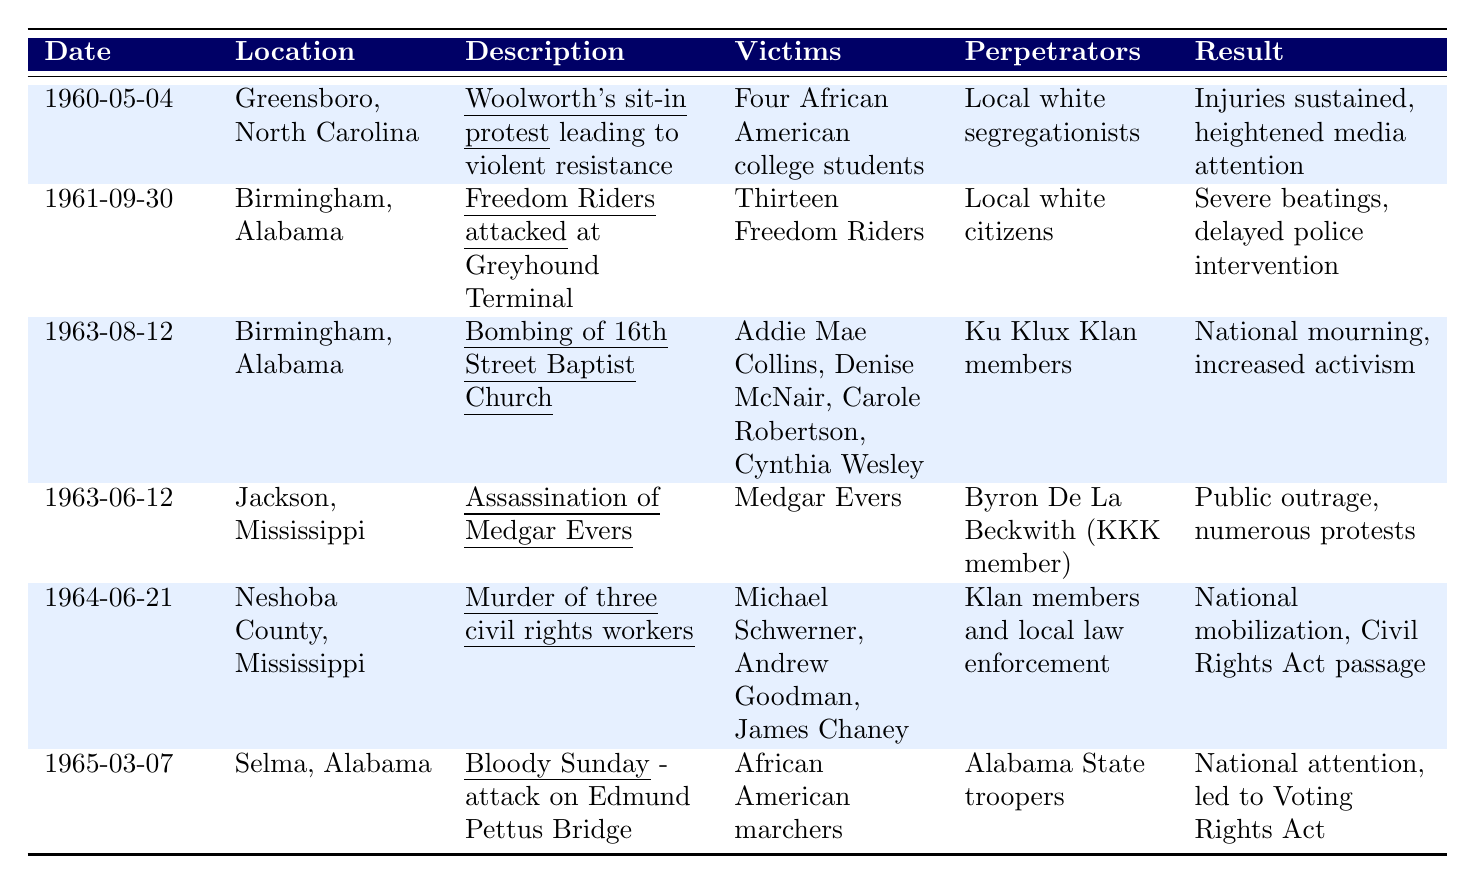What incident occurred on May 4, 1960? The table indicates that on May 4, 1960, in Greensboro, North Carolina, a Woolworth's sit-in protest led to violent resistance from white patrons.
Answer: Woolworth's sit-in protest How many victims were involved in the Freedom Riders incident? Referring to the table, it states that the Freedom Riders incident on September 30, 1961, involved thirteen victims.
Answer: Thirteen victims Which location had the bombing incident? According to the table, the bombing of the 16th Street Baptist Church occurred in Birmingham, Alabama, on August 12, 1963.
Answer: Birmingham, Alabama True or False: The assassination of Medgar Evers was committed by a Ku Klux Klan member. The table shows that Medgar Evers was assassinated by Byron De La Beckwith, who was a member of the Ku Klux Klan, making the statement true.
Answer: True What were the results of the incident on March 7, 1965? The results of the Bloody Sunday incident in Selma, Alabama, on March 7, 1965, included national attention and led to the Voting Rights Act of 1965, as indicated in the table.
Answer: National attention, led to Voting Rights Act Which incident had the most victims? By comparing the number of victims in each incident from the table, the incident involving the bombing of the 16th Street Baptist Church had four victims: Addie Mae Collins, Denise McNair, Carole Robertson, and Cynthia Wesley, while other incidents had fewer victims.
Answer: Bombing of the 16th Street Baptist Church How many years are between the first and last incidents listed? The first incident occurred in 1960 and the last incident in 1965, so the difference is 1965 - 1960, which equals 5 years.
Answer: 5 years Which incidents resulted in national mobilization or attention? Referring to the table, both the murder of three civil rights workers and Bloody Sunday resulted in national mobilization and national attention, respectively.
Answer: Murder of three civil rights workers and Bloody Sunday 